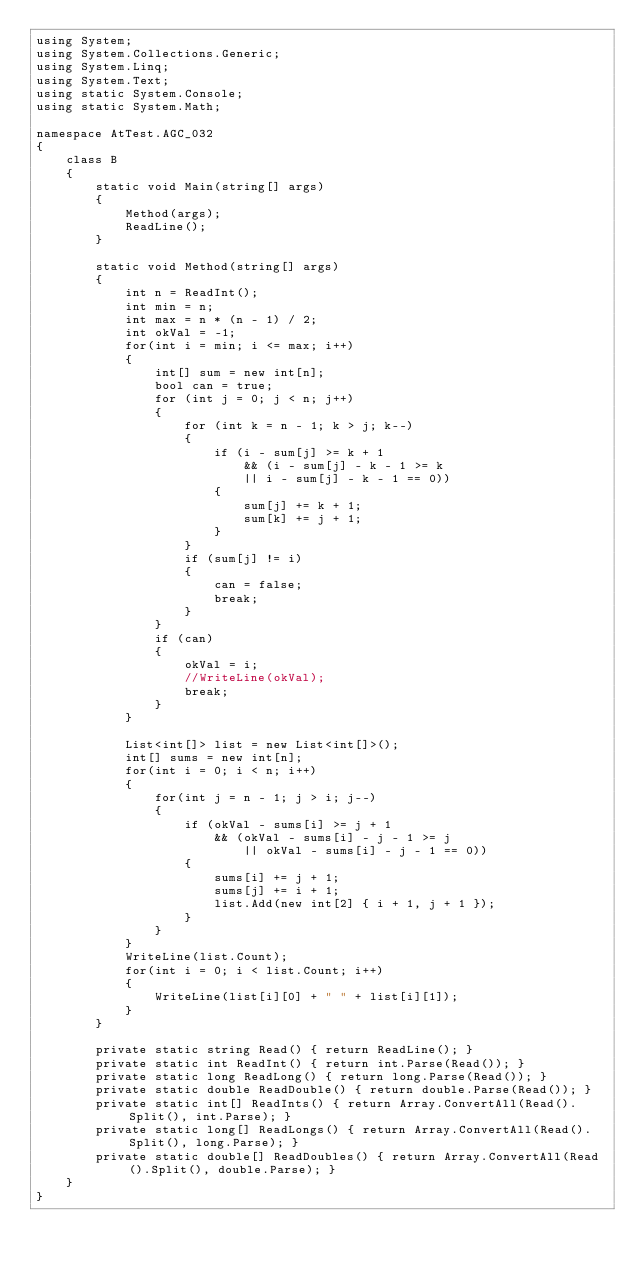Convert code to text. <code><loc_0><loc_0><loc_500><loc_500><_C#_>using System;
using System.Collections.Generic;
using System.Linq;
using System.Text;
using static System.Console;
using static System.Math;

namespace AtTest.AGC_032
{
    class B
    {
        static void Main(string[] args)
        {
            Method(args);
            ReadLine();
        }

        static void Method(string[] args)
        {
            int n = ReadInt();
            int min = n;
            int max = n * (n - 1) / 2;
            int okVal = -1;
            for(int i = min; i <= max; i++)
            {
                int[] sum = new int[n];
                bool can = true;
                for (int j = 0; j < n; j++)
                {
                    for (int k = n - 1; k > j; k--)
                    {
                        if (i - sum[j] >= k + 1
                            && (i - sum[j] - k - 1 >= k
                            || i - sum[j] - k - 1 == 0))
                        {
                            sum[j] += k + 1;
                            sum[k] += j + 1;
                        }
                    }
                    if (sum[j] != i)
                    {
                        can = false;
                        break;
                    }
                }
                if (can)
                {
                    okVal = i;
                    //WriteLine(okVal);
                    break;
                }
            }

            List<int[]> list = new List<int[]>();
            int[] sums = new int[n];
            for(int i = 0; i < n; i++)
            {
                for(int j = n - 1; j > i; j--)
                {
                    if (okVal - sums[i] >= j + 1 
                        && (okVal - sums[i] - j - 1 >= j
                            || okVal - sums[i] - j - 1 == 0))
                    {
                        sums[i] += j + 1;
                        sums[j] += i + 1;
                        list.Add(new int[2] { i + 1, j + 1 });
                    }
                }
            }
            WriteLine(list.Count);
            for(int i = 0; i < list.Count; i++)
            {
                WriteLine(list[i][0] + " " + list[i][1]);
            }
        }

        private static string Read() { return ReadLine(); }
        private static int ReadInt() { return int.Parse(Read()); }
        private static long ReadLong() { return long.Parse(Read()); }
        private static double ReadDouble() { return double.Parse(Read()); }
        private static int[] ReadInts() { return Array.ConvertAll(Read().Split(), int.Parse); }
        private static long[] ReadLongs() { return Array.ConvertAll(Read().Split(), long.Parse); }
        private static double[] ReadDoubles() { return Array.ConvertAll(Read().Split(), double.Parse); }
    }
}
</code> 